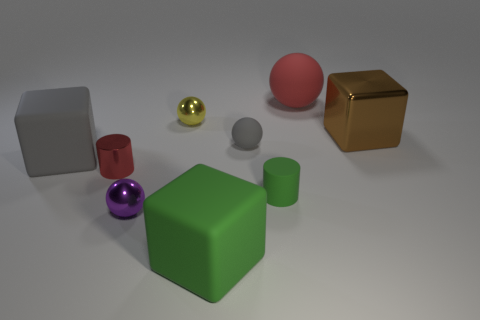What number of yellow things are either tiny rubber objects or shiny spheres?
Give a very brief answer. 1. Is there a brown shiny cube of the same size as the yellow metal object?
Make the answer very short. No. What is the red thing to the right of the red metallic thing to the left of the small metal sphere behind the tiny purple metal thing made of?
Provide a succinct answer. Rubber. Are there the same number of cylinders that are to the right of the green cylinder and small blue metallic blocks?
Provide a short and direct response. Yes. Do the red object behind the metallic block and the red thing that is in front of the brown thing have the same material?
Make the answer very short. No. What number of objects are yellow shiny balls or spheres in front of the yellow shiny object?
Offer a very short reply. 3. Are there any large purple rubber things of the same shape as the small green matte thing?
Make the answer very short. No. What size is the red thing on the left side of the green matte thing behind the green thing left of the small matte cylinder?
Your response must be concise. Small. Is the number of gray matte spheres to the right of the brown shiny object the same as the number of metallic cubes that are behind the tiny green rubber thing?
Offer a very short reply. No. What is the size of the cylinder that is made of the same material as the green cube?
Ensure brevity in your answer.  Small. 